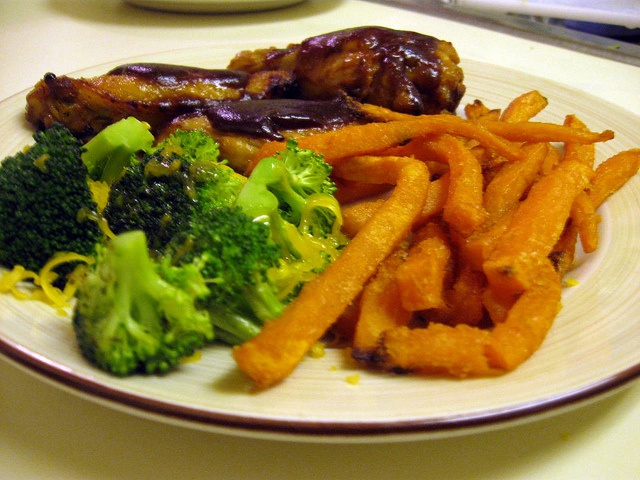Describe the objects in this image and their specific colors. I can see dining table in tan, beige, and olive tones, broccoli in tan, black, darkgreen, and olive tones, carrot in tan, orange, red, and maroon tones, carrot in tan, orange, red, and maroon tones, and carrot in tan, orange, red, and maroon tones in this image. 